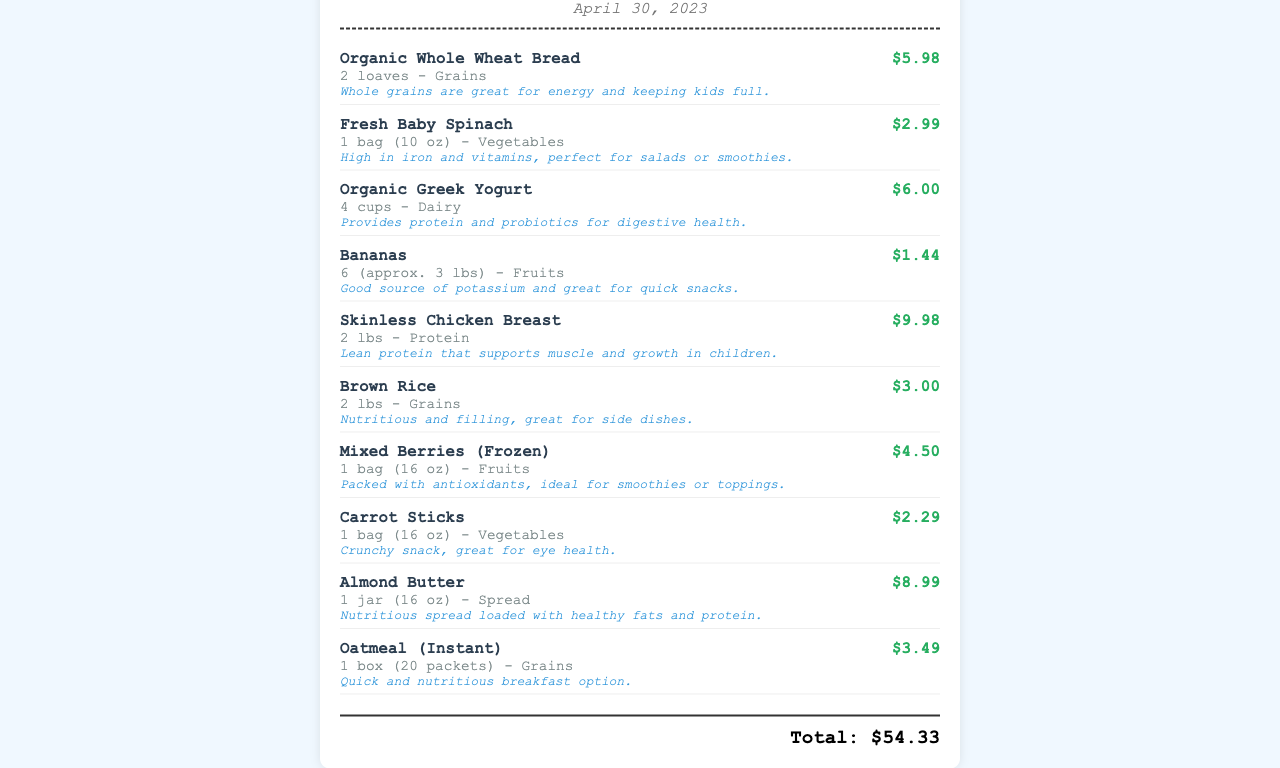What is the date of the receipt? The date of the receipt is specifically mentioned in the document as April 30, 2023.
Answer: April 30, 2023 How many loaves of bread were purchased? The receipt indicates that 2 loaves of Organic Whole Wheat Bread were bought.
Answer: 2 loaves What is a benefit of Fresh Baby Spinach? The document states that Fresh Baby Spinach is high in iron and vitamins, making it beneficial for health.
Answer: High in iron and vitamins What is the price of Organic Greek Yogurt? Organic Greek Yogurt is listed with a price of $6.00 on the receipt.
Answer: $6.00 How many pounds of skinless chicken breast were bought? The receipt shows that 2 lbs of Skinless Chicken Breast were purchased.
Answer: 2 lbs What type of food is indicated as a snack? The document suggests that Bananas are a good source for quick snacks.
Answer: Bananas What is the total amount spent on this grocery receipt? The total amount spent is calculated as the sum of all item prices, which equals $54.33.
Answer: $54.33 Which item provides protein and probiotics? The item that provides protein and probiotics, as mentioned in the document, is Organic Greek Yogurt.
Answer: Organic Greek Yogurt What type of product is Almond Butter categorized as? Almond Butter is categorized as a spread in the document.
Answer: Spread 